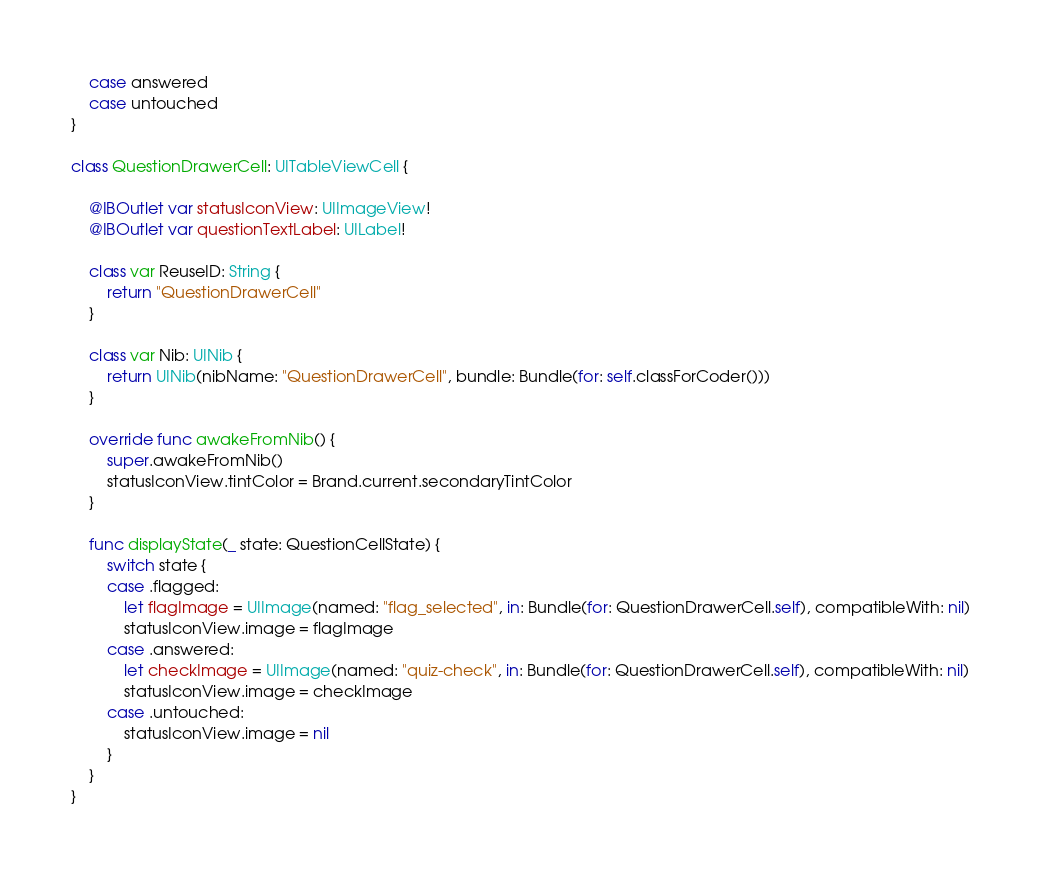<code> <loc_0><loc_0><loc_500><loc_500><_Swift_>    case answered
    case untouched
}

class QuestionDrawerCell: UITableViewCell {

    @IBOutlet var statusIconView: UIImageView!
    @IBOutlet var questionTextLabel: UILabel!
    
    class var ReuseID: String {
        return "QuestionDrawerCell"
    }
    
    class var Nib: UINib {
        return UINib(nibName: "QuestionDrawerCell", bundle: Bundle(for: self.classForCoder()))
    }
    
    override func awakeFromNib() {
        super.awakeFromNib()
        statusIconView.tintColor = Brand.current.secondaryTintColor
    }
    
    func displayState(_ state: QuestionCellState) {
        switch state {
        case .flagged:
            let flagImage = UIImage(named: "flag_selected", in: Bundle(for: QuestionDrawerCell.self), compatibleWith: nil)
            statusIconView.image = flagImage
        case .answered:
            let checkImage = UIImage(named: "quiz-check", in: Bundle(for: QuestionDrawerCell.self), compatibleWith: nil)
            statusIconView.image = checkImage
        case .untouched:
            statusIconView.image = nil
        }
    }
}
</code> 